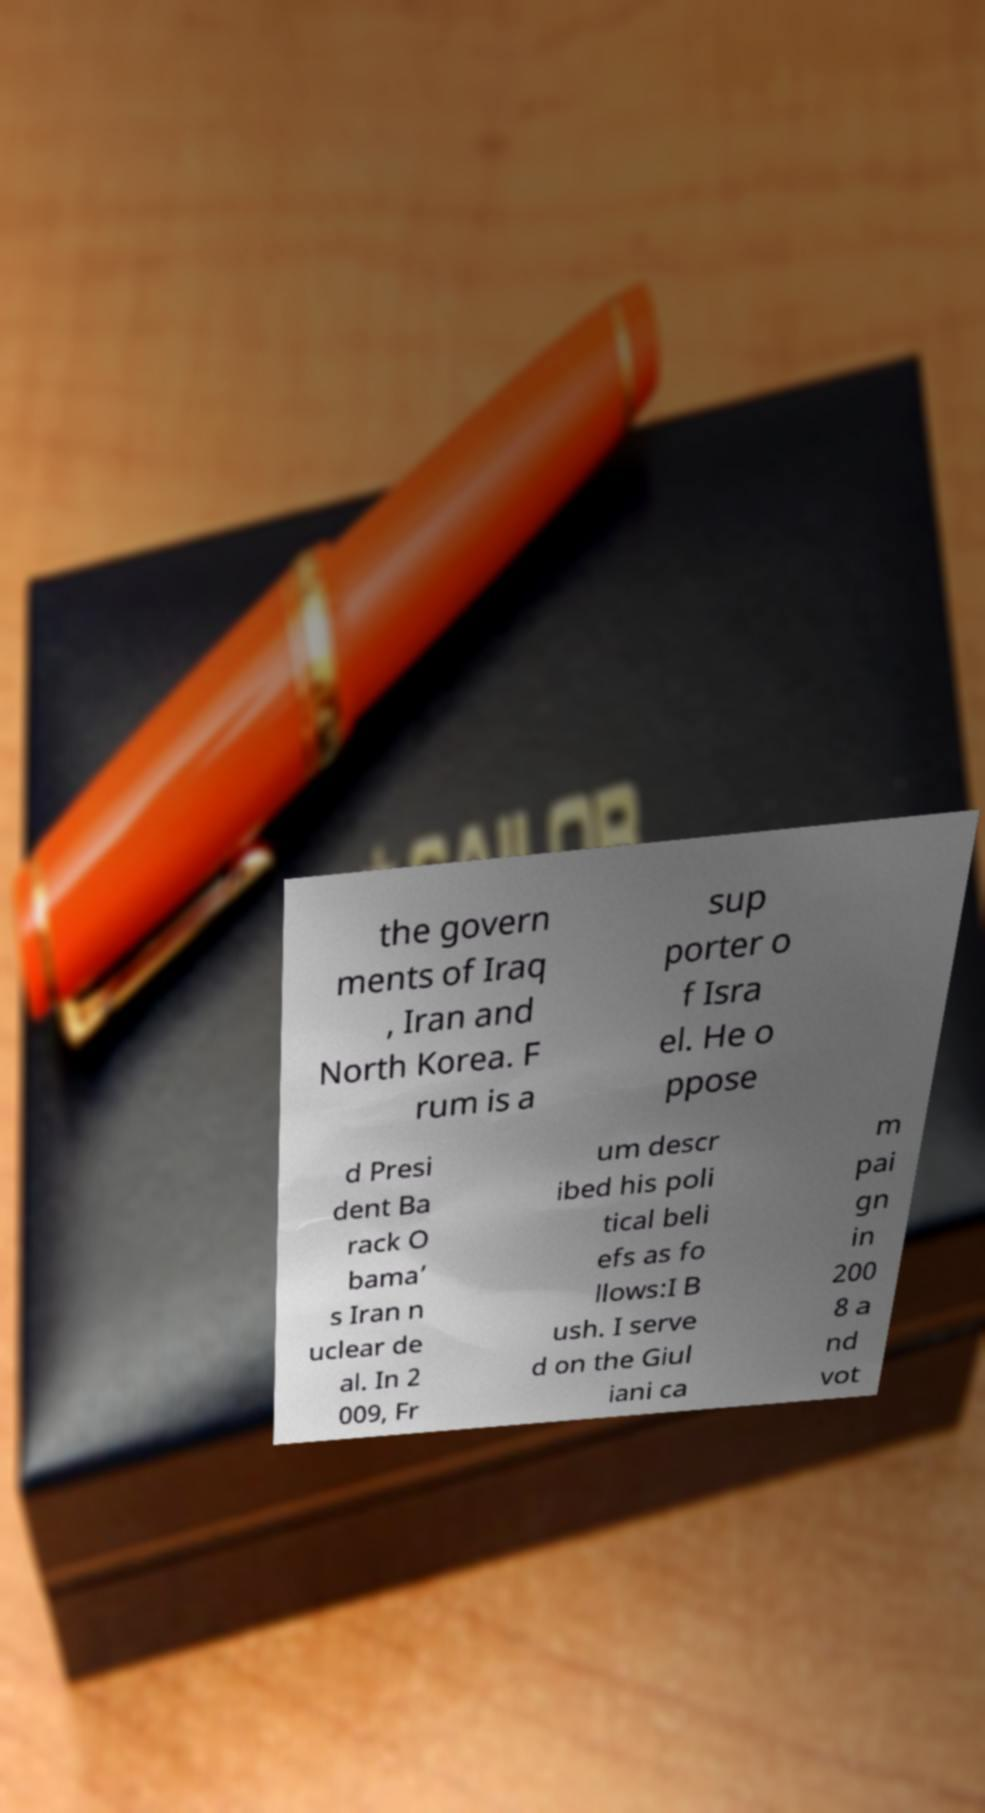Can you read and provide the text displayed in the image?This photo seems to have some interesting text. Can you extract and type it out for me? the govern ments of Iraq , Iran and North Korea. F rum is a sup porter o f Isra el. He o ppose d Presi dent Ba rack O bama’ s Iran n uclear de al. In 2 009, Fr um descr ibed his poli tical beli efs as fo llows:I B ush. I serve d on the Giul iani ca m pai gn in 200 8 a nd vot 